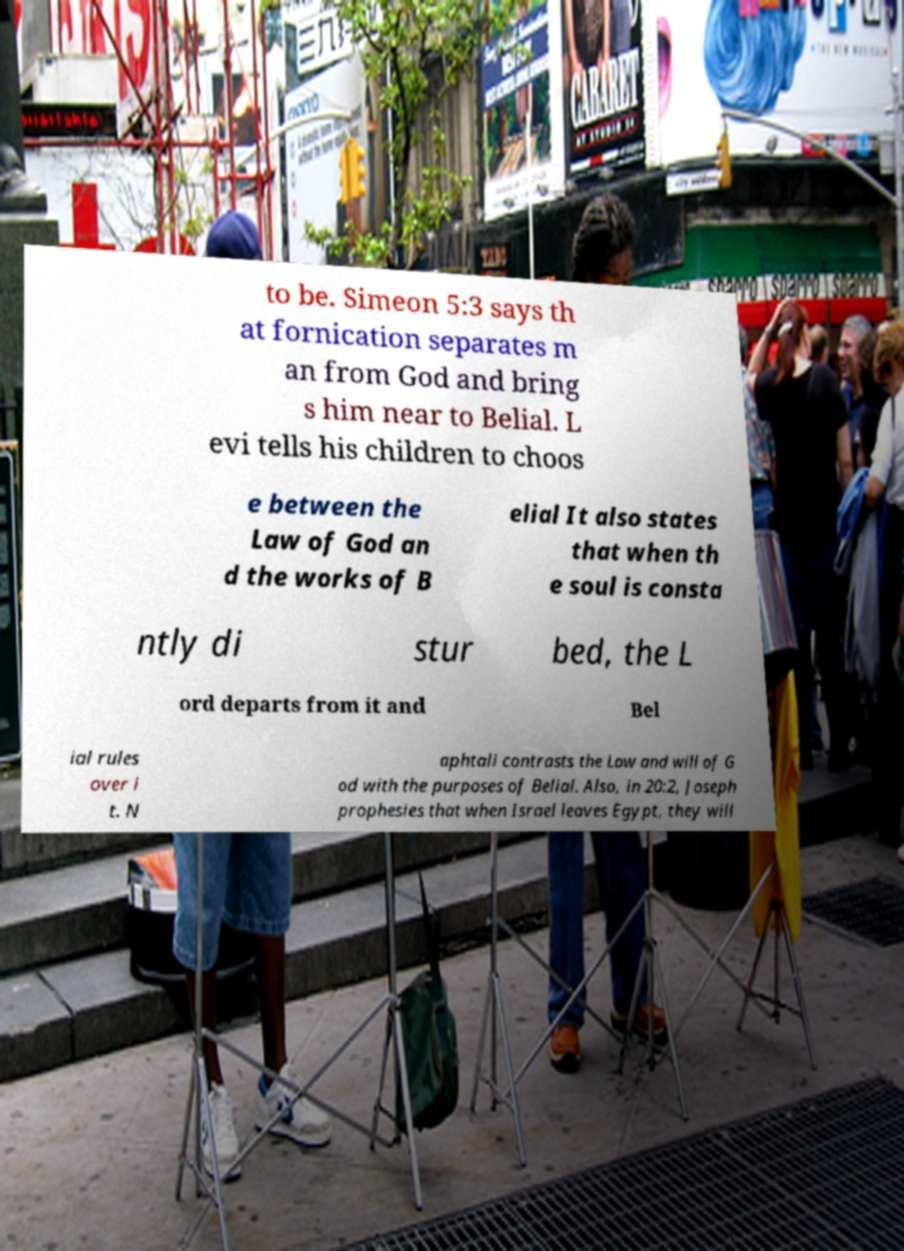Could you extract and type out the text from this image? to be. Simeon 5:3 says th at fornication separates m an from God and bring s him near to Belial. L evi tells his children to choos e between the Law of God an d the works of B elial It also states that when th e soul is consta ntly di stur bed, the L ord departs from it and Bel ial rules over i t. N aphtali contrasts the Law and will of G od with the purposes of Belial. Also, in 20:2, Joseph prophesies that when Israel leaves Egypt, they will 